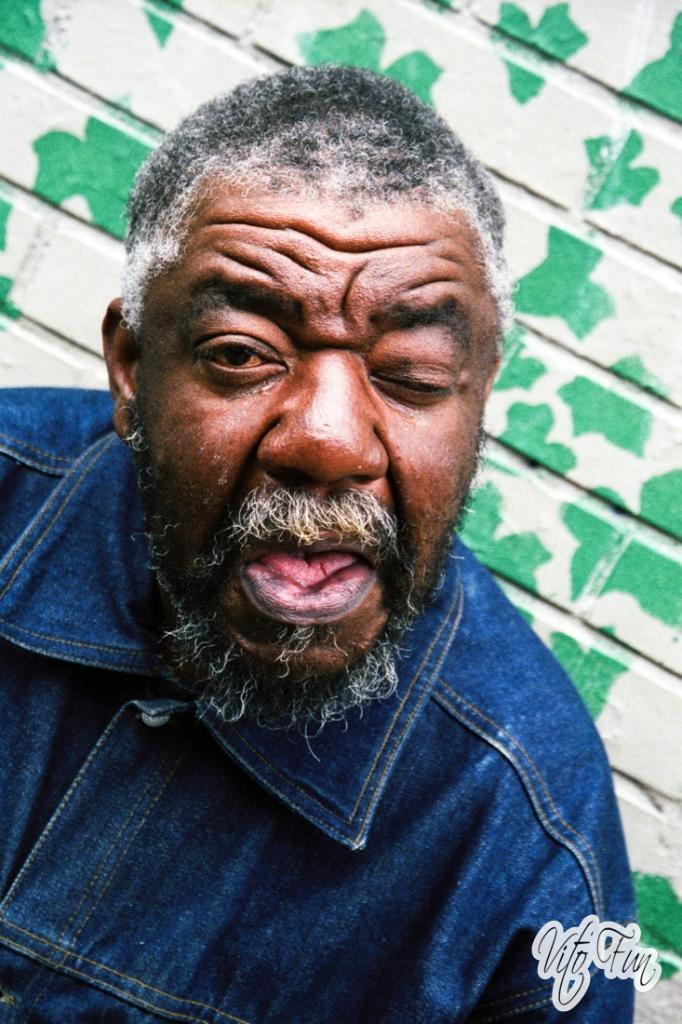Who is present in the image? There is a man in the image. What can be seen in the background of the image? There is a wall in the background of the image. Is there any text visible in the image? Yes, there is some text in the bottom right corner of the image. Can you see the manager giving a kiss to the harbor in the image? There is no manager or harbor present in the image, and therefore no such activity can be observed. 